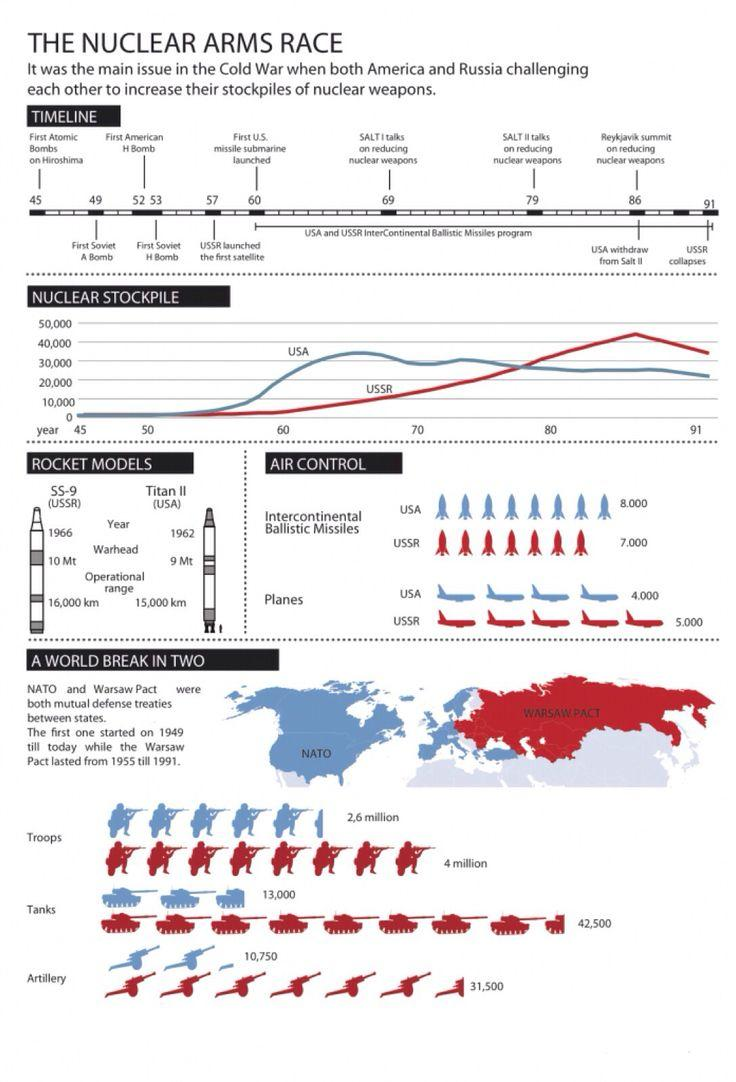Indicate a few pertinent items in this graphic. The Titan II's warhead possesses a length of 9 megatons. The Warsaw Pact deployed approximately 31,500 artilleries during a certain time period. The first Titan II missile was launched by the United States in 1962. 4 million troops were deployed in the Warsaw Pact. As of the most recent information available, it is estimated that approximately 13,000 military tankers were deployed by NATO. 